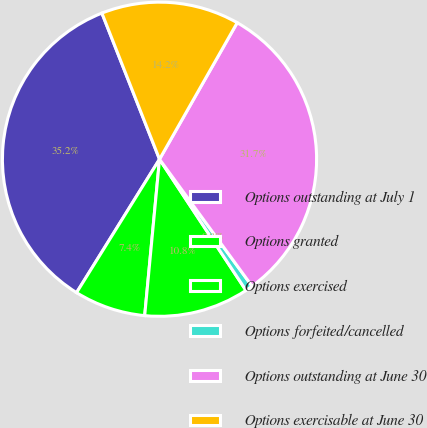Convert chart. <chart><loc_0><loc_0><loc_500><loc_500><pie_chart><fcel>Options outstanding at July 1<fcel>Options granted<fcel>Options exercised<fcel>Options forfeited/cancelled<fcel>Options outstanding at June 30<fcel>Options exercisable at June 30<nl><fcel>35.17%<fcel>7.35%<fcel>10.78%<fcel>0.75%<fcel>31.74%<fcel>14.21%<nl></chart> 